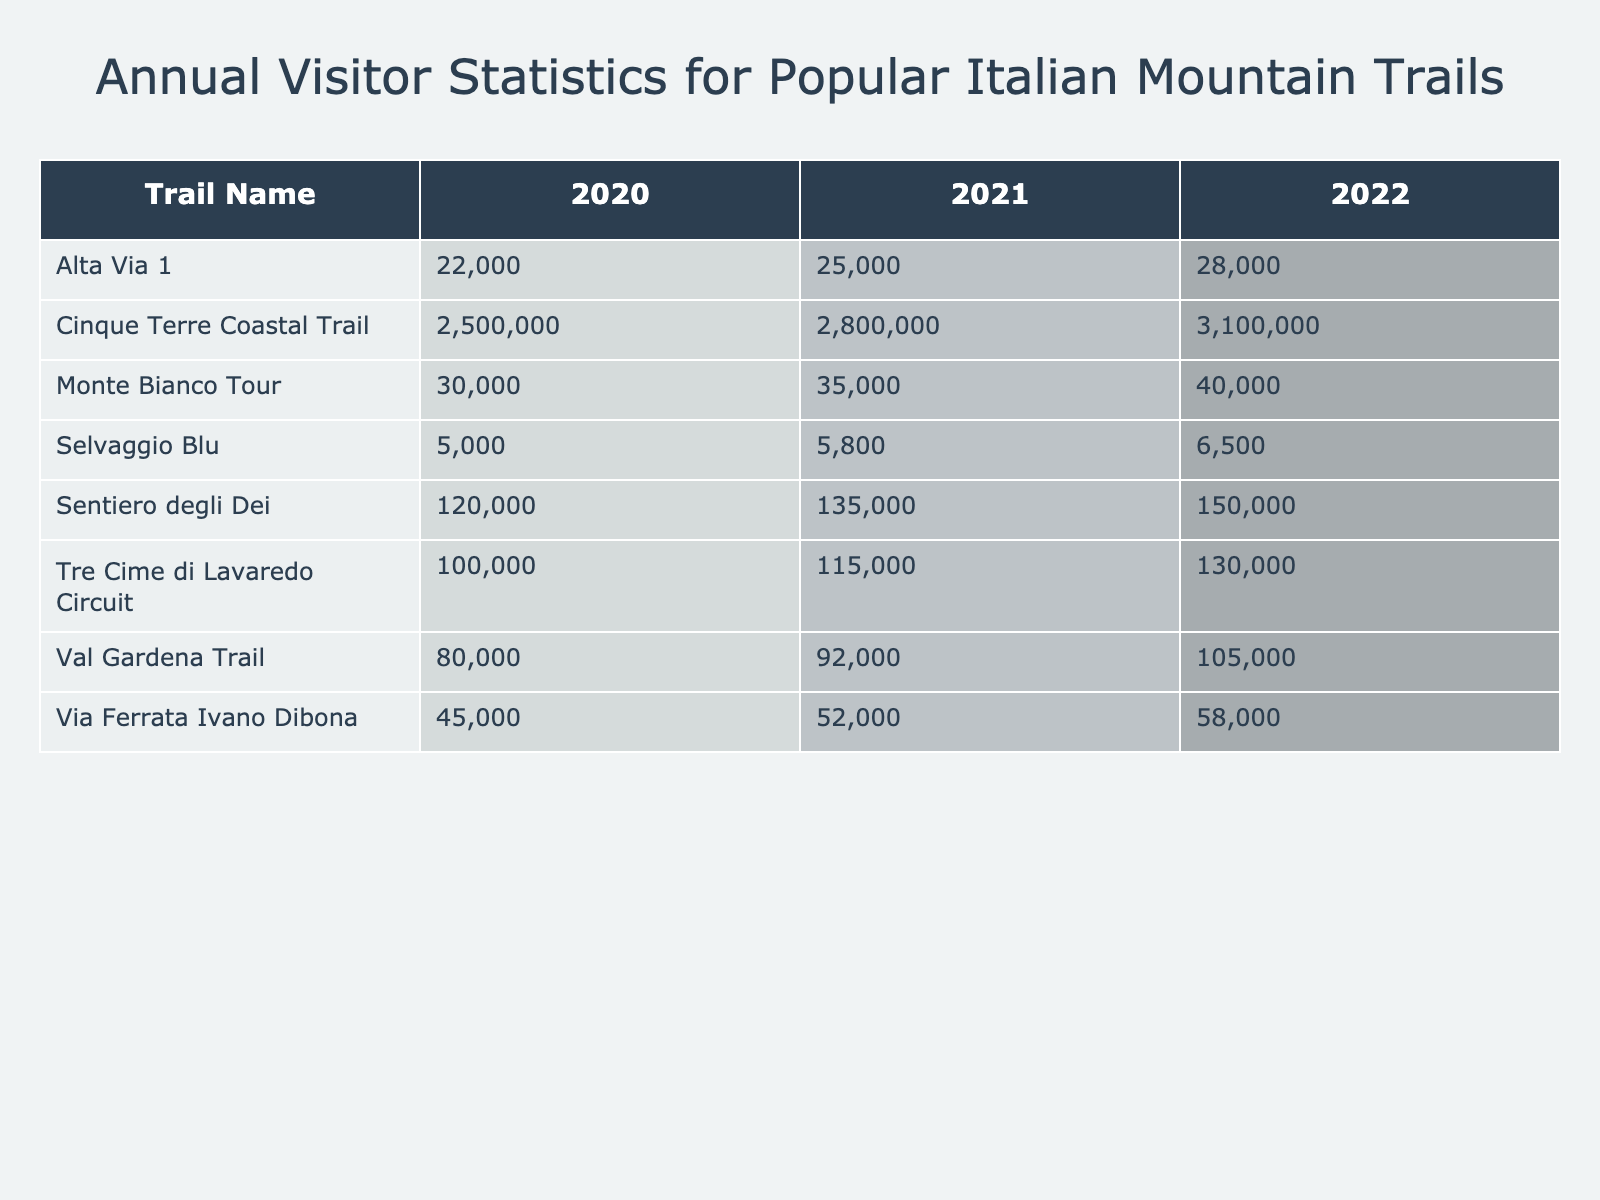What trail had the highest annual visitors in 2022? The table shows the annual visitors for each trail in 2022. By comparing the values, the Cinque Terre Coastal Trail had 3,100,000 visitors, which is higher than any other trail listed.
Answer: Cinque Terre Coastal Trail Which trail saw the smallest number of visitors in 2020? The table lists the annual visitors for all trails in 2020. The Selvaggio Blu had the least with 5,000 visitors.
Answer: Selvaggio Blu What was the percentage increase in visitors for Sentiero degli Dei from 2020 to 2021? The number of visitors in 2020 was 120,000 and in 2021 it was 135,000. The increase is 135,000 - 120,000 = 15,000. To find the percentage increase: (15,000/120,000) * 100 = 12.5%.
Answer: 12.5% Which trail's visitors in 2021 were greater than the average number of visitors across all trails in 2021? First, I calculate the average visitors for 2021 by summing the visitors of all trails (52,000 + 135,000 + 25,000 + 2,800,000 + 115,000 + 92,000 + 35,000 + 5,800) and dividing by 8. The average is 406,100. The trails with visitors greater than this average are Sentiero degli Dei and Cinque Terre Coastal Trail.
Answer: Sentiero degli Dei and Cinque Terre Coastal Trail How many visitors did Val Gardena Trail have in 2022, and how does that compare to its visitors in 2020? Val Gardena Trail had 105,000 visitors in 2022 and 80,000 in 2020. The difference is 105,000 - 80,000 = 25,000, which means it had 25,000 more visitors in 2022.
Answer: 105,000 Was the number of visitors for Via Ferrata Ivano Dibona in 2021 higher than for Monte Bianco Tour in the same year? According to the table, Via Ferrata Ivano Dibona had 52,000 visitors in 2021 and Monte Bianco Tour had 35,000. Since 52,000 is greater than 35,000, the statement is true.
Answer: Yes Which trail had the highest overall increase in visitors from 2020 to 2022? To find this, I look at the visitors in 2020 and 2022 for each trail and calculate the difference. The Cinque Terre Coastal Trail increased from 2,500,000 to 3,100,000, a difference of 600,000. This is greater than any other trail's increase.
Answer: Cinque Terre Coastal Trail Is it true that the visitors for Tre Cime di Lavaredo Circuit increased each year from 2020 to 2022? Checking the visitors from the table, in 2020 there were 100,000, in 2021 there were 115,000, and in 2022 there were 130,000. Since each year had a higher number than the previous one, the statement is true.
Answer: Yes What was the total number of visitors for Alta Via 1 over the three years? To find the total, I sum the visitors for Alta Via 1: 22,000 + 25,000 + 28,000 = 75,000.
Answer: 75,000 Which trail gained the least number of visitors between 2021 and 2022? Analyzing the visitor numbers for 2021 and 2022, Selvaggio Blu had a change from 5,800 to 6,500, which is an increase of 700. The other trails had greater increases than this.
Answer: Selvaggio Blu If we consider only the trails with over 100,000 visitors in 2022, how many visitors did they have in total? The trails with over 100,000 visitors in 2022 are Cinque Terre Coastal Trail (3,100,000), Sentiero degli Dei (150,000), Tre Cime di Lavaredo Circuit (130,000), and Val Gardena Trail (105,000). Their total is 3,100,000 + 150,000 + 130,000 + 105,000 = 3,485,000.
Answer: 3,485,000 